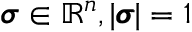<formula> <loc_0><loc_0><loc_500><loc_500>\pm b { \sigma } \in \mathbb { R } ^ { n } , | \pm b { \sigma } | = 1</formula> 